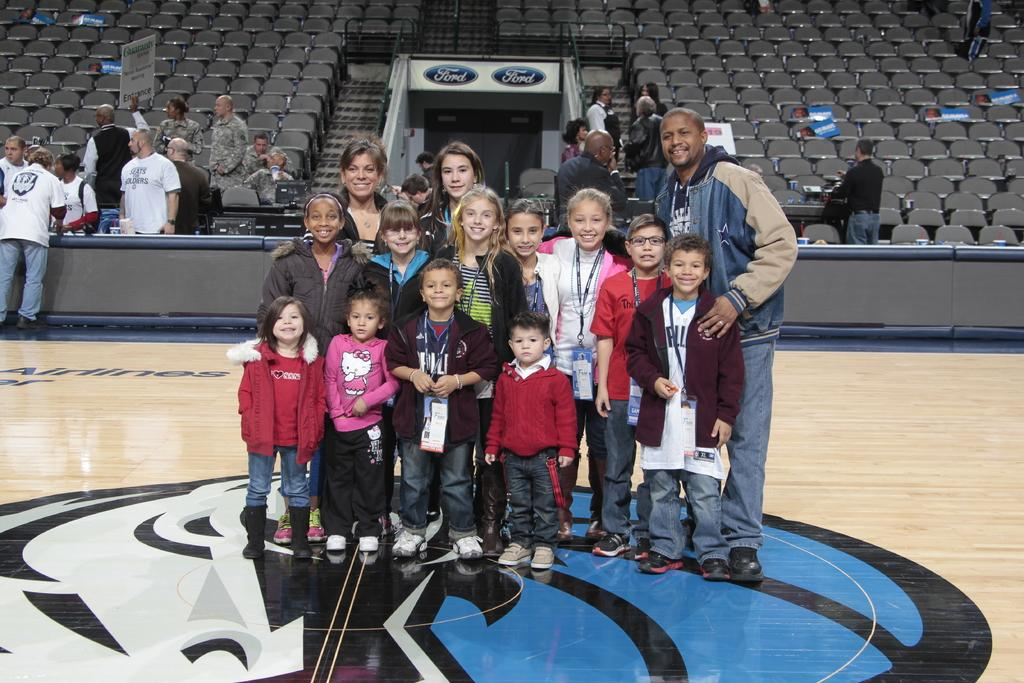How many kids are in the image? There are a few kids in the image. How many adults are in the image? There are two adults in the image. Where are the kids and adults standing? They are standing in a court. What is the general mood of the people in the image? The people in the image are smiling. What are the kids and adults doing in the image? They are posing for the camera. Are there any spectators in the image? Yes, there are a few people on the stands behind them. What type of rock can be seen in the image? There is no rock present in the image. How much coal is visible in the image? There is no coal present in the image. 